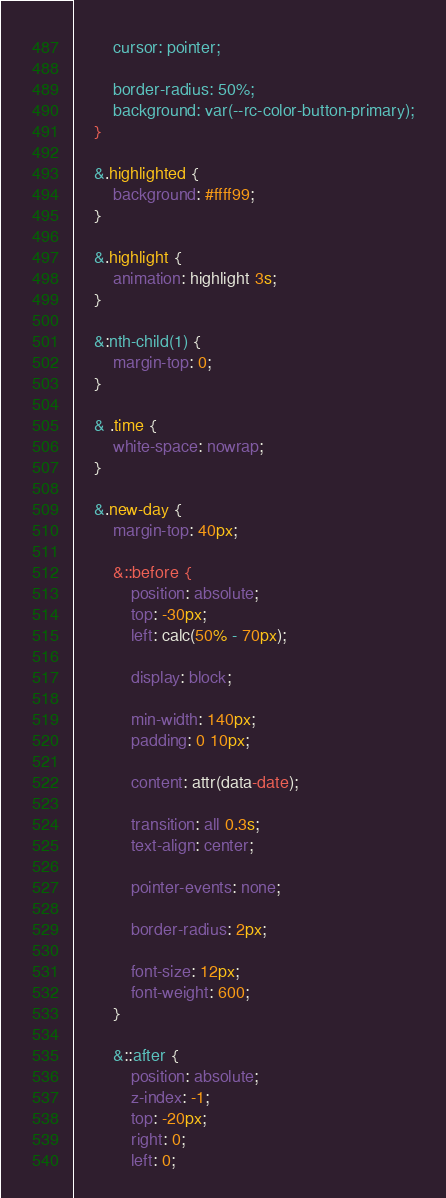<code> <loc_0><loc_0><loc_500><loc_500><_CSS_>
		cursor: pointer;

		border-radius: 50%;
		background: var(--rc-color-button-primary);
	}

	&.highlighted {
		background: #ffff99;
	}

	&.highlight {
		animation: highlight 3s;
	}

	&:nth-child(1) {
		margin-top: 0;
	}

	& .time {
		white-space: nowrap;
	}

	&.new-day {
		margin-top: 40px;

		&::before {
			position: absolute;
			top: -30px;
			left: calc(50% - 70px);

			display: block;

			min-width: 140px;
			padding: 0 10px;

			content: attr(data-date);

			transition: all 0.3s;
			text-align: center;

			pointer-events: none;

			border-radius: 2px;

			font-size: 12px;
			font-weight: 600;
		}

		&::after {
			position: absolute;
			z-index: -1;
			top: -20px;
			right: 0;
			left: 0;
</code> 